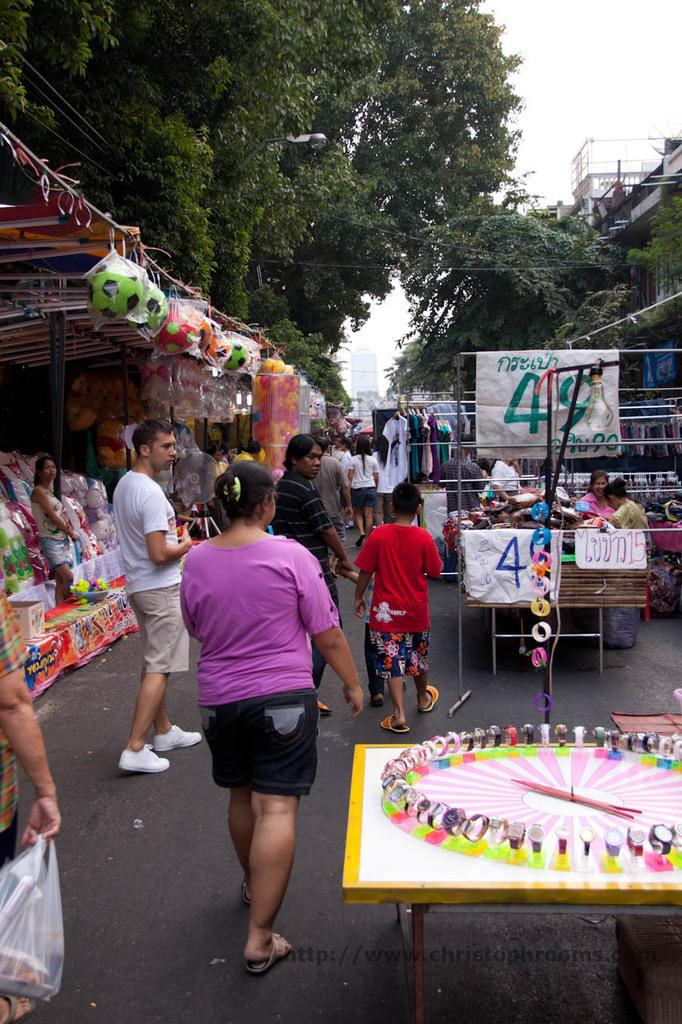What are the people in the image doing? There is a group of people walking on the road in the image. What else can be seen in the image besides the people walking? There are stalls, balls, trees, and toys in the image. Can you describe the environment in the image? The image shows a scene with trees and stalls, and the sky is visible in the background. What type of oatmeal is being served at the stalls in the image? There is no mention of oatmeal in the image; it does not appear to be present. 